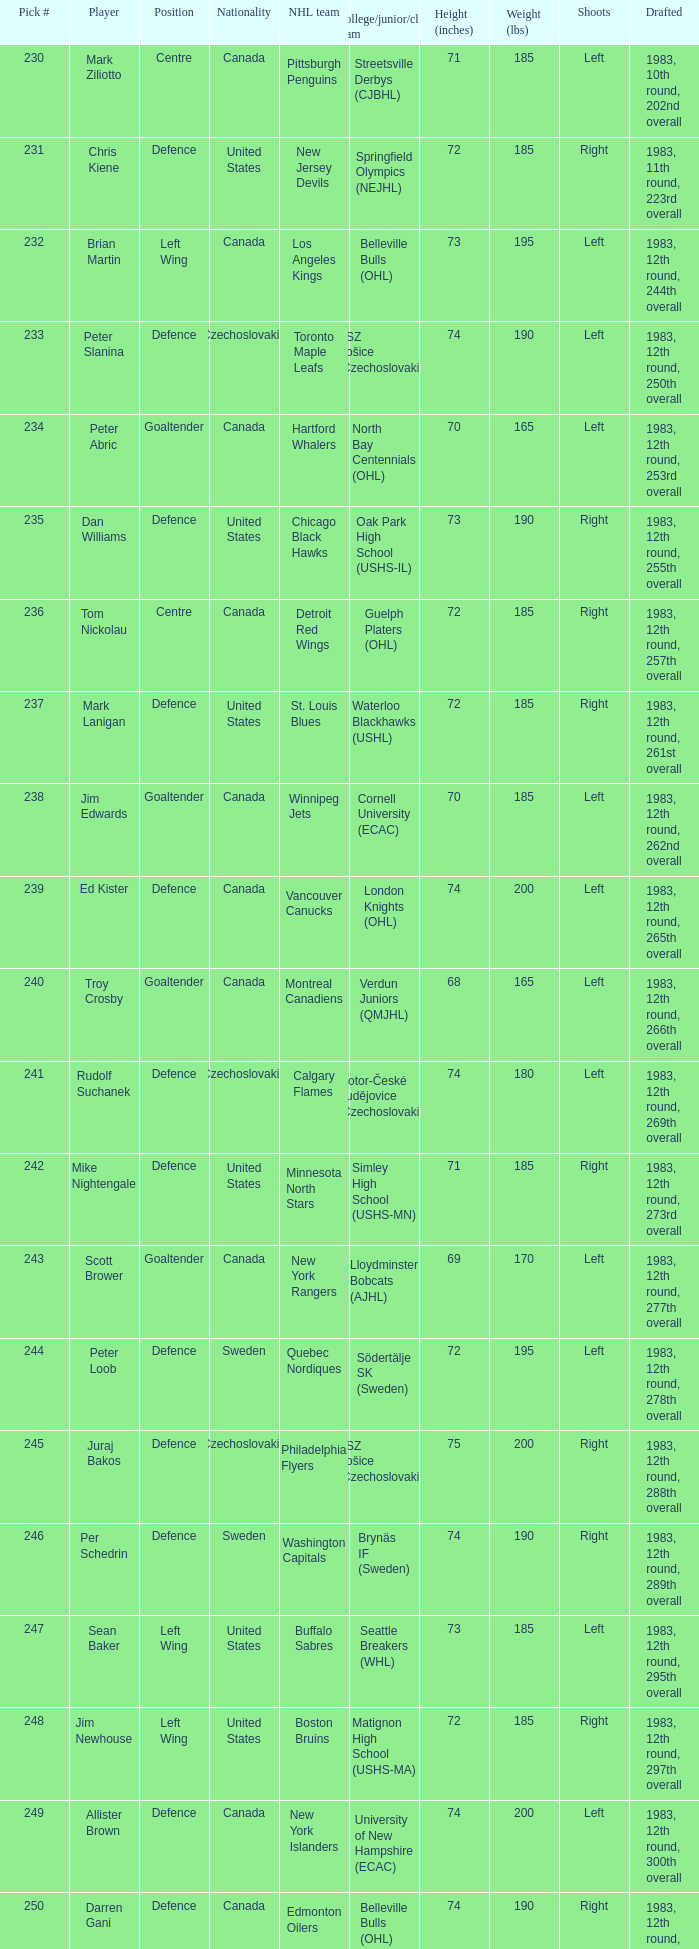What selection was the springfield olympics (nejhl)? 231.0. 